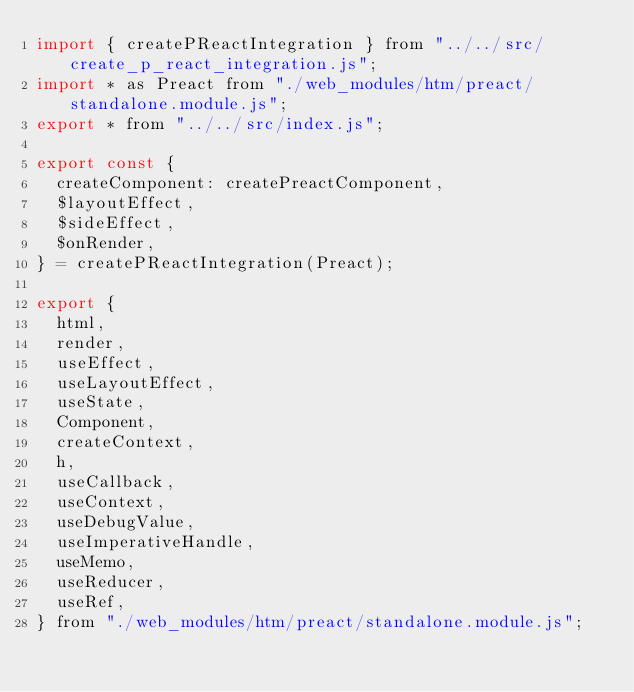<code> <loc_0><loc_0><loc_500><loc_500><_JavaScript_>import { createPReactIntegration } from "../../src/create_p_react_integration.js";
import * as Preact from "./web_modules/htm/preact/standalone.module.js";
export * from "../../src/index.js";

export const {
  createComponent: createPreactComponent,
  $layoutEffect,
  $sideEffect,
  $onRender,
} = createPReactIntegration(Preact);

export {
  html,
  render,
  useEffect,
  useLayoutEffect,
  useState,
  Component,
  createContext,
  h,
  useCallback,
  useContext,
  useDebugValue,
  useImperativeHandle,
  useMemo,
  useReducer,
  useRef,
} from "./web_modules/htm/preact/standalone.module.js";
</code> 